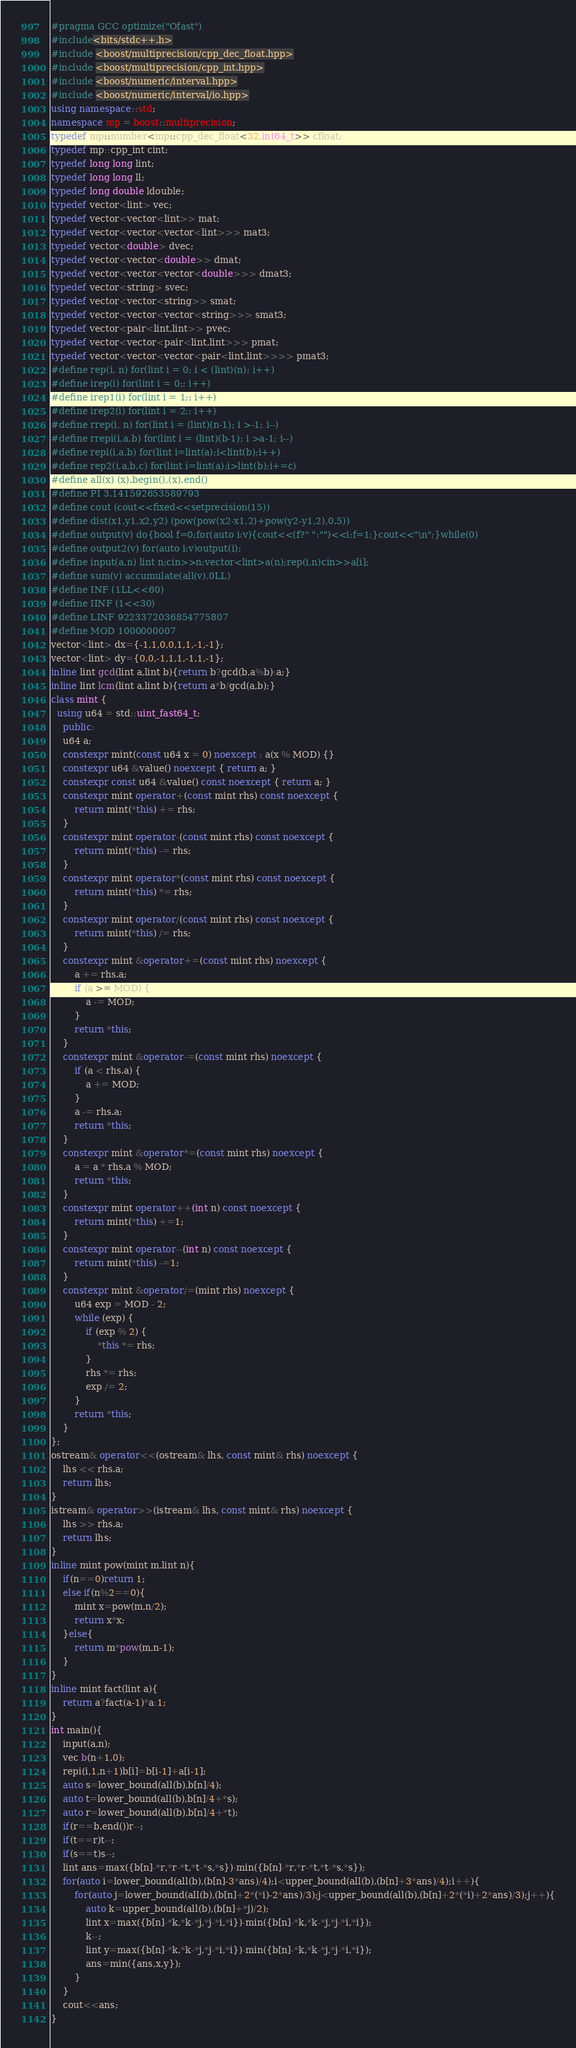Convert code to text. <code><loc_0><loc_0><loc_500><loc_500><_C++_>#pragma GCC optimize("Ofast")
#include<bits/stdc++.h>
#include <boost/multiprecision/cpp_dec_float.hpp>
#include <boost/multiprecision/cpp_int.hpp>
#include <boost/numeric/interval.hpp>
#include <boost/numeric/interval/io.hpp>
using namespace::std;
namespace mp = boost::multiprecision;
typedef mp::number<mp::cpp_dec_float<32,int64_t>> cfloat;
typedef mp::cpp_int cint;
typedef long long lint;
typedef long long ll;
typedef long double ldouble;
typedef vector<lint> vec;
typedef vector<vector<lint>> mat;
typedef vector<vector<vector<lint>>> mat3;
typedef vector<double> dvec;
typedef vector<vector<double>> dmat;
typedef vector<vector<vector<double>>> dmat3;
typedef vector<string> svec;
typedef vector<vector<string>> smat;
typedef vector<vector<vector<string>>> smat3;
typedef vector<pair<lint,lint>> pvec;
typedef vector<vector<pair<lint,lint>>> pmat;
typedef vector<vector<vector<pair<lint,lint>>>> pmat3;
#define rep(i, n) for(lint i = 0; i < (lint)(n); i++)
#define irep(i) for(lint i = 0;; i++)
#define irep1(i) for(lint i = 1;; i++)
#define irep2(i) for(lint i = 2;; i++)
#define rrep(i, n) for(lint i = (lint)(n-1); i >-1; i--)
#define rrepi(i,a,b) for(lint i = (lint)(b-1); i >a-1; i--)
#define repi(i,a,b) for(lint i=lint(a);i<lint(b);i++)
#define rep2(i,a,b,c) for(lint i=lint(a);i>lint(b);i+=c)
#define all(x) (x).begin(),(x).end()
#define PI 3.141592653589793
#define cout (cout<<fixed<<setprecision(15))
#define dist(x1,y1,x2,y2) (pow(pow(x2-x1,2)+pow(y2-y1,2),0.5))
#define output(v) do{bool f=0;for(auto i:v){cout<<(f?" ":"")<<i;f=1;}cout<<"\n";}while(0)
#define output2(v) for(auto i:v)output(i);
#define input(a,n) lint n;cin>>n;vector<lint>a(n);rep(i,n)cin>>a[i];
#define sum(v) accumulate(all(v),0LL)
#define INF (1LL<<60)
#define IINF (1<<30)
#define LINF 9223372036854775807
#define MOD 1000000007
vector<lint> dx={-1,1,0,0,1,1,-1,-1};
vector<lint> dy={0,0,-1,1,1,-1,1,-1};
inline lint gcd(lint a,lint b){return b?gcd(b,a%b):a;}
inline lint lcm(lint a,lint b){return a*b/gcd(a,b);}
class mint {
  using u64 = std::uint_fast64_t;
    public:
    u64 a;
    constexpr mint(const u64 x = 0) noexcept : a(x % MOD) {}
    constexpr u64 &value() noexcept { return a; }
    constexpr const u64 &value() const noexcept { return a; }
    constexpr mint operator+(const mint rhs) const noexcept {
        return mint(*this) += rhs;
    }
    constexpr mint operator-(const mint rhs) const noexcept {
        return mint(*this) -= rhs;
    }
    constexpr mint operator*(const mint rhs) const noexcept {
        return mint(*this) *= rhs;
    }
    constexpr mint operator/(const mint rhs) const noexcept {
        return mint(*this) /= rhs;
    }
    constexpr mint &operator+=(const mint rhs) noexcept {
        a += rhs.a;
        if (a >= MOD) {
            a -= MOD;
        }
        return *this;
    }
    constexpr mint &operator-=(const mint rhs) noexcept {
        if (a < rhs.a) {
            a += MOD;
        }
        a -= rhs.a;
        return *this;
    }
    constexpr mint &operator*=(const mint rhs) noexcept {
        a = a * rhs.a % MOD;
        return *this;
    }
    constexpr mint operator++(int n) const noexcept {
        return mint(*this) +=1;
    }
    constexpr mint operator--(int n) const noexcept {
        return mint(*this) -=1;
    }
    constexpr mint &operator/=(mint rhs) noexcept {
        u64 exp = MOD - 2;
        while (exp) {
            if (exp % 2) {
                *this *= rhs;
            }
            rhs *= rhs;
            exp /= 2;
        }
        return *this;
    }
};
ostream& operator<<(ostream& lhs, const mint& rhs) noexcept {
    lhs << rhs.a;
    return lhs;
}
istream& operator>>(istream& lhs, const mint& rhs) noexcept {
    lhs >> rhs.a;
    return lhs;
}
inline mint pow(mint m,lint n){
    if(n==0)return 1;
    else if(n%2==0){
        mint x=pow(m,n/2);
        return x*x;
    }else{
        return m*pow(m,n-1);
    }
}
inline mint fact(lint a){
    return a?fact(a-1)*a:1;
}
int main(){
    input(a,n);
    vec b(n+1,0);
    repi(i,1,n+1)b[i]=b[i-1]+a[i-1];
    auto s=lower_bound(all(b),b[n]/4);
    auto t=lower_bound(all(b),b[n]/4+*s);
    auto r=lower_bound(all(b),b[n]/4+*t);
    if(r==b.end())r--;
    if(t==r)t--;
    if(s==t)s--;
    lint ans=max({b[n]-*r,*r-*t,*t-*s,*s})-min({b[n]-*r,*r-*t,*t-*s,*s});
    for(auto i=lower_bound(all(b),(b[n]-3*ans)/4);i<upper_bound(all(b),(b[n]+3*ans)/4);i++){
        for(auto j=lower_bound(all(b),(b[n]+2*(*i)-2*ans)/3);j<upper_bound(all(b),(b[n]+2*(*i)+2*ans)/3);j++){
            auto k=upper_bound(all(b),(b[n]+*j)/2);
            lint x=max({b[n]-*k,*k-*j,*j-*i,*i})-min({b[n]-*k,*k-*j,*j-*i,*i});
            k--;
            lint y=max({b[n]-*k,*k-*j,*j-*i,*i})-min({b[n]-*k,*k-*j,*j-*i,*i});
            ans=min({ans,x,y});
        }
    }
    cout<<ans;
}</code> 